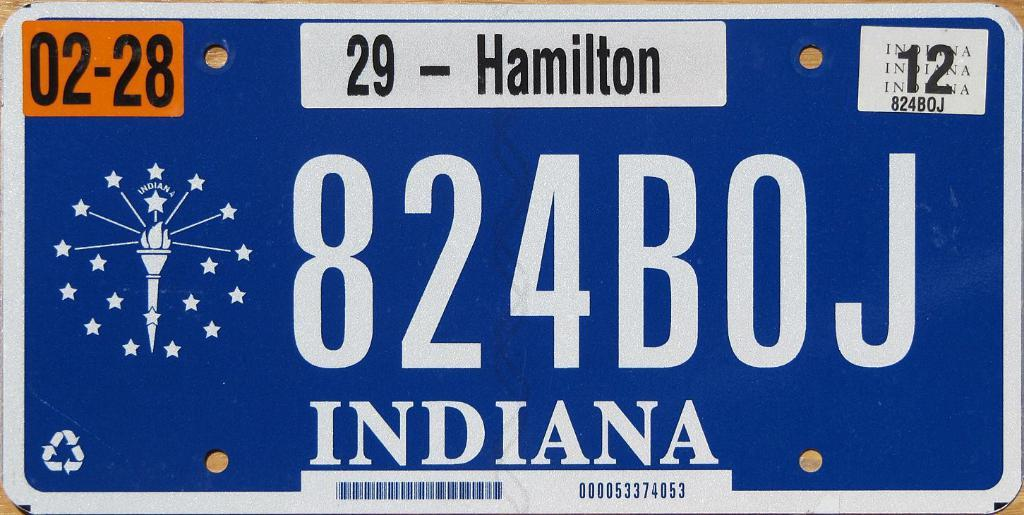<image>
Render a clear and concise summary of the photo. An Indiana license plate reads 824BOJ underneath 29 - Hamilton. 